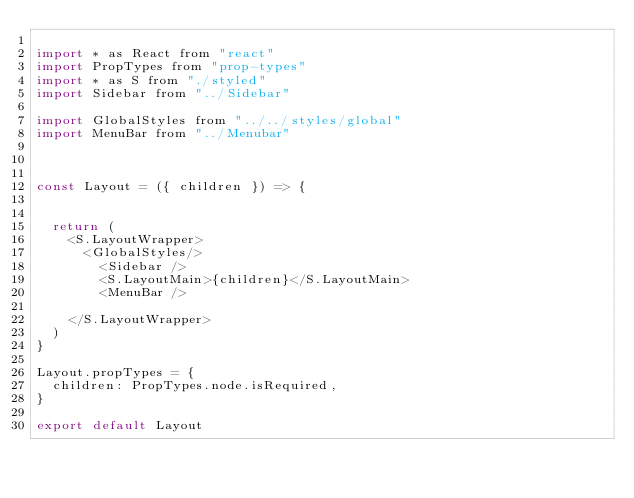<code> <loc_0><loc_0><loc_500><loc_500><_JavaScript_>
import * as React from "react"
import PropTypes from "prop-types"
import * as S from "./styled"
import Sidebar from "../Sidebar"

import GlobalStyles from "../../styles/global"
import MenuBar from "../Menubar"



const Layout = ({ children }) => {
  

  return (
    <S.LayoutWrapper>
      <GlobalStyles/>
        <Sidebar />
        <S.LayoutMain>{children}</S.LayoutMain>
        <MenuBar />
        
    </S.LayoutWrapper>
  )
}

Layout.propTypes = {
  children: PropTypes.node.isRequired,
}

export default Layout
</code> 